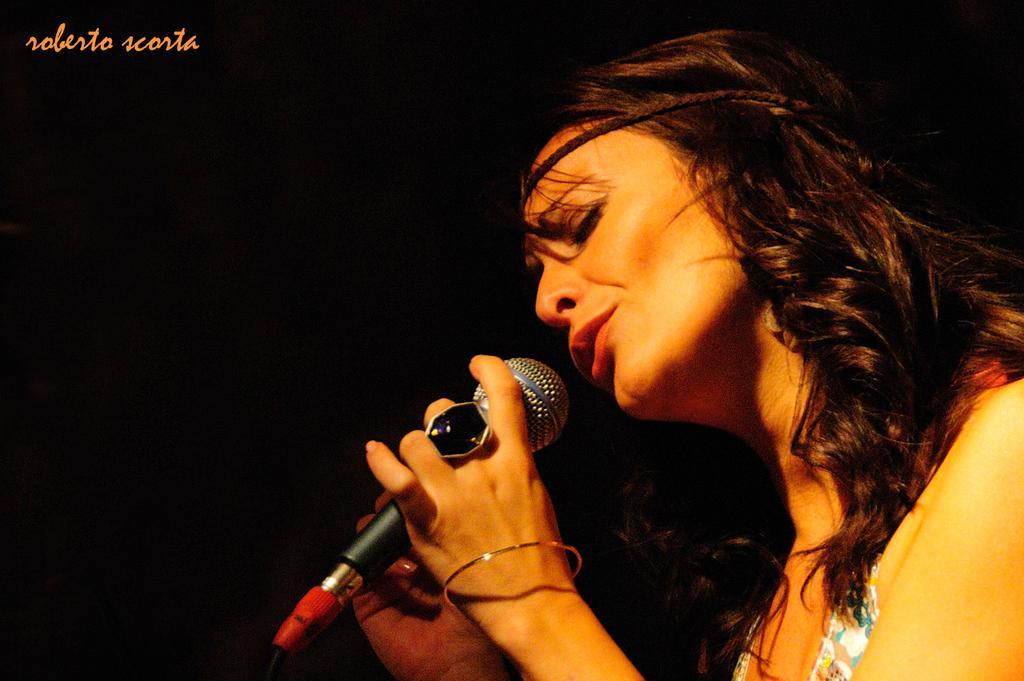Can you describe this image briefly? There is a woman holding a mic in her hand and singing in front of it and there is something written in the left top corner. 